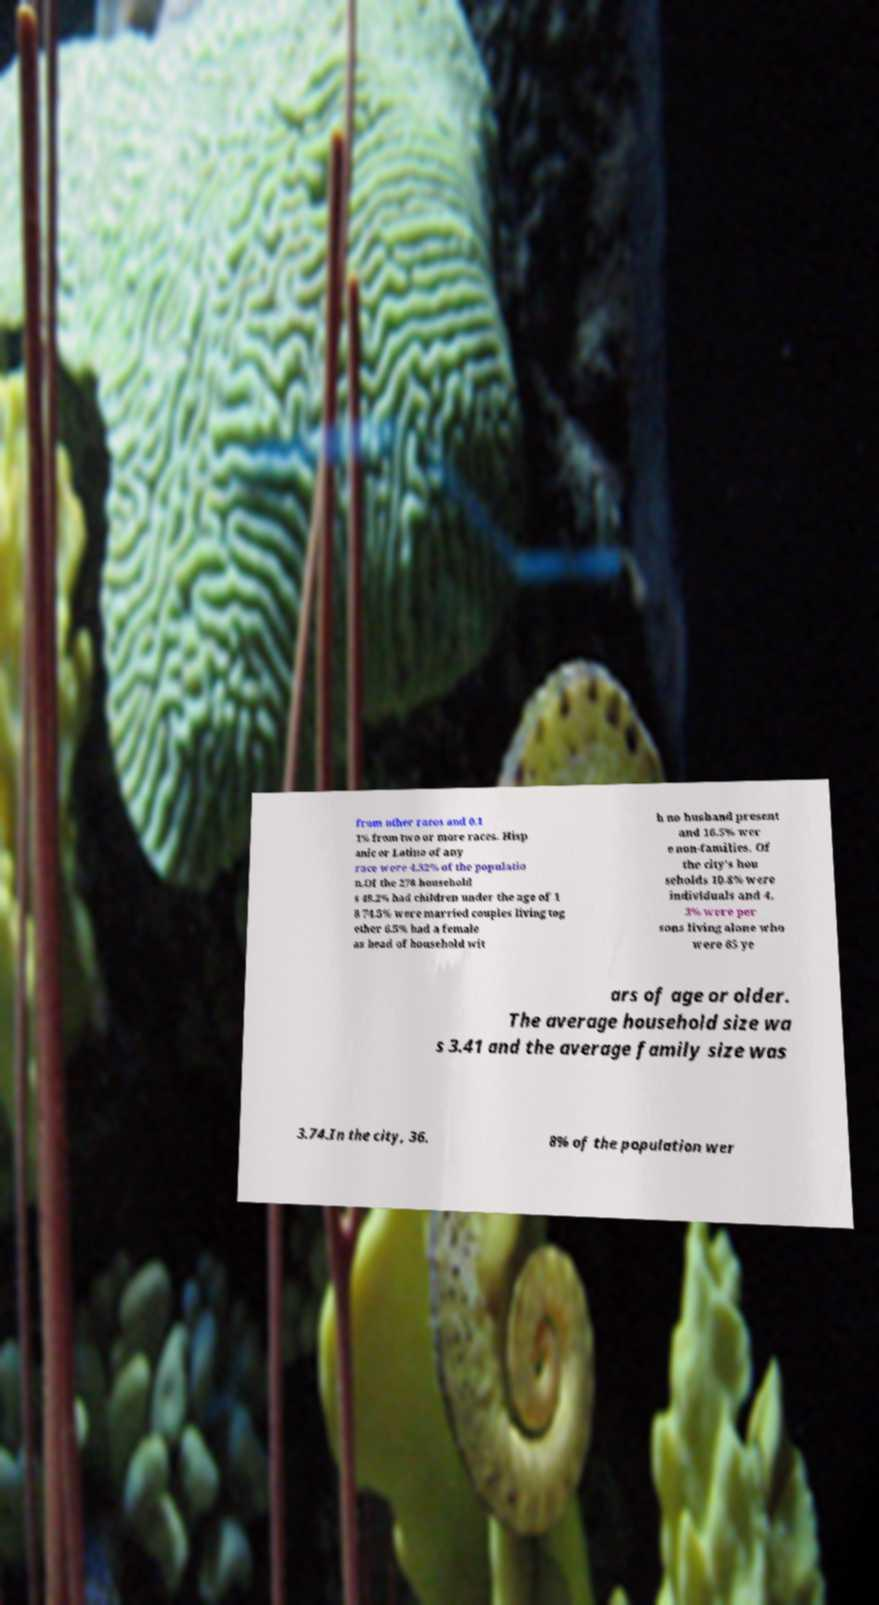Could you extract and type out the text from this image? from other races and 0.1 1% from two or more races. Hisp anic or Latino of any race were 4.32% of the populatio n.Of the 278 household s 48.2% had children under the age of 1 8 74.5% were married couples living tog ether 6.5% had a female as head of household wit h no husband present and 16.5% wer e non-families. Of the city's hou seholds 10.8% were individuals and 4. 3% were per sons living alone who were 65 ye ars of age or older. The average household size wa s 3.41 and the average family size was 3.74.In the city, 36. 8% of the population wer 